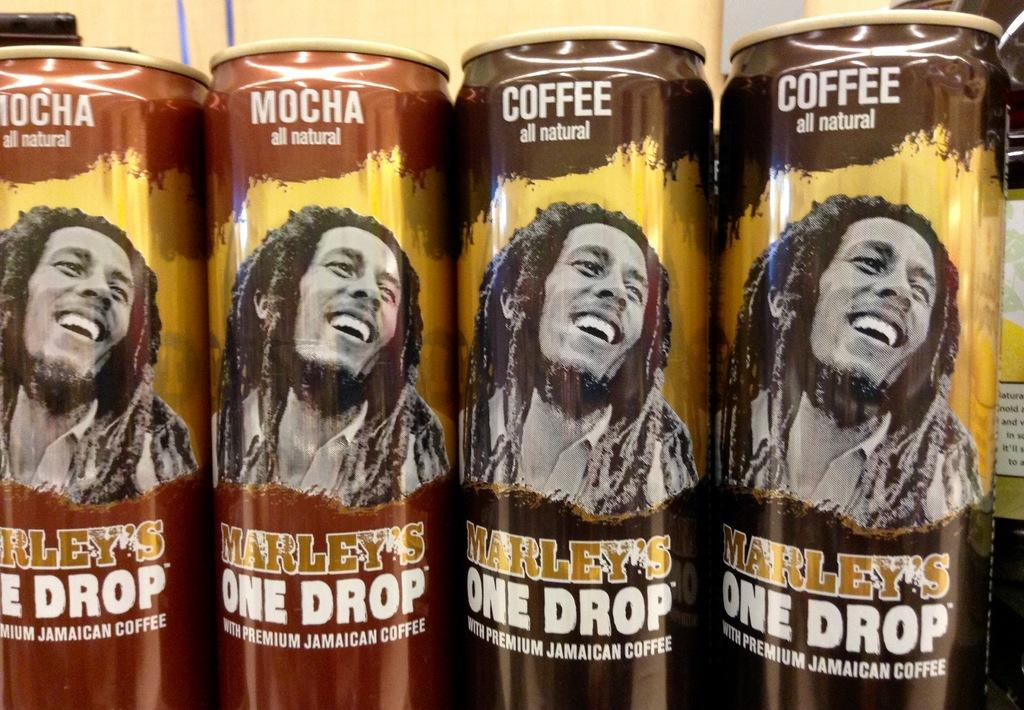<image>
Render a clear and concise summary of the photo. A collection of Marley's one drop Jamaican coffee. 